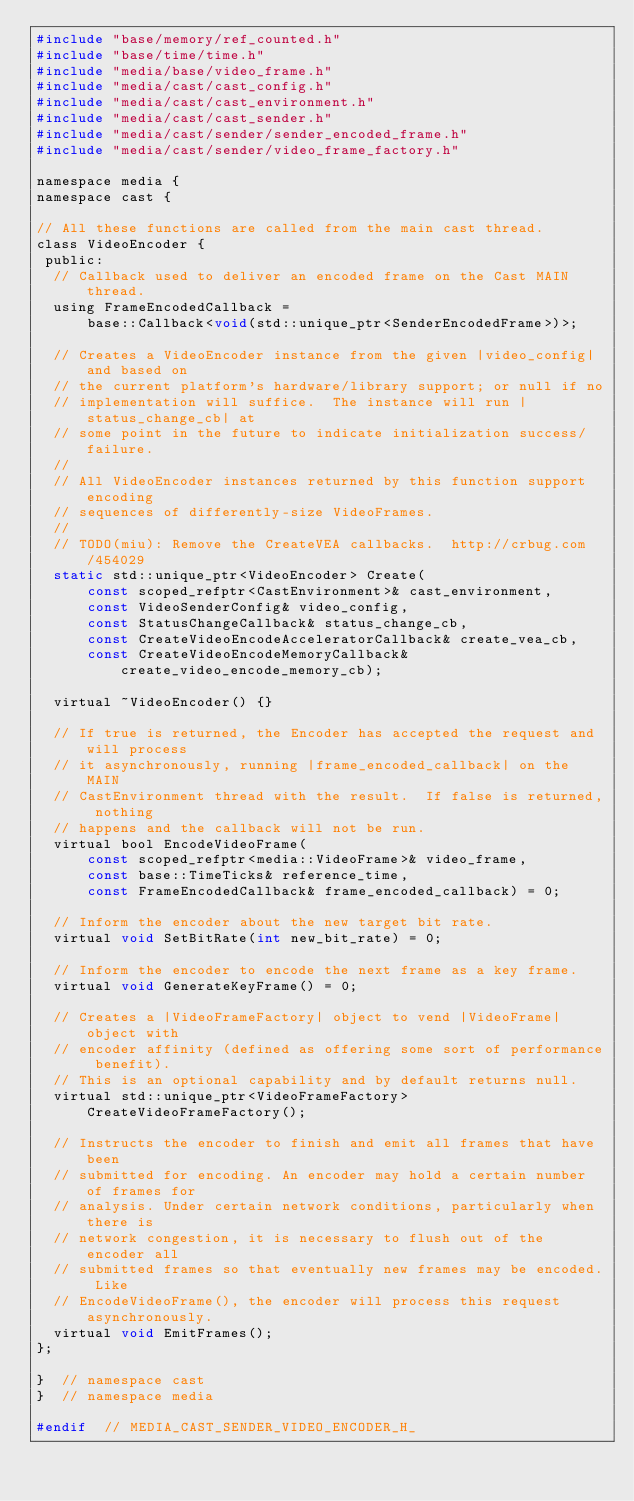Convert code to text. <code><loc_0><loc_0><loc_500><loc_500><_C_>#include "base/memory/ref_counted.h"
#include "base/time/time.h"
#include "media/base/video_frame.h"
#include "media/cast/cast_config.h"
#include "media/cast/cast_environment.h"
#include "media/cast/cast_sender.h"
#include "media/cast/sender/sender_encoded_frame.h"
#include "media/cast/sender/video_frame_factory.h"

namespace media {
namespace cast {

// All these functions are called from the main cast thread.
class VideoEncoder {
 public:
  // Callback used to deliver an encoded frame on the Cast MAIN thread.
  using FrameEncodedCallback =
      base::Callback<void(std::unique_ptr<SenderEncodedFrame>)>;

  // Creates a VideoEncoder instance from the given |video_config| and based on
  // the current platform's hardware/library support; or null if no
  // implementation will suffice.  The instance will run |status_change_cb| at
  // some point in the future to indicate initialization success/failure.
  //
  // All VideoEncoder instances returned by this function support encoding
  // sequences of differently-size VideoFrames.
  //
  // TODO(miu): Remove the CreateVEA callbacks.  http://crbug.com/454029
  static std::unique_ptr<VideoEncoder> Create(
      const scoped_refptr<CastEnvironment>& cast_environment,
      const VideoSenderConfig& video_config,
      const StatusChangeCallback& status_change_cb,
      const CreateVideoEncodeAcceleratorCallback& create_vea_cb,
      const CreateVideoEncodeMemoryCallback& create_video_encode_memory_cb);

  virtual ~VideoEncoder() {}

  // If true is returned, the Encoder has accepted the request and will process
  // it asynchronously, running |frame_encoded_callback| on the MAIN
  // CastEnvironment thread with the result.  If false is returned, nothing
  // happens and the callback will not be run.
  virtual bool EncodeVideoFrame(
      const scoped_refptr<media::VideoFrame>& video_frame,
      const base::TimeTicks& reference_time,
      const FrameEncodedCallback& frame_encoded_callback) = 0;

  // Inform the encoder about the new target bit rate.
  virtual void SetBitRate(int new_bit_rate) = 0;

  // Inform the encoder to encode the next frame as a key frame.
  virtual void GenerateKeyFrame() = 0;

  // Creates a |VideoFrameFactory| object to vend |VideoFrame| object with
  // encoder affinity (defined as offering some sort of performance benefit).
  // This is an optional capability and by default returns null.
  virtual std::unique_ptr<VideoFrameFactory> CreateVideoFrameFactory();

  // Instructs the encoder to finish and emit all frames that have been
  // submitted for encoding. An encoder may hold a certain number of frames for
  // analysis. Under certain network conditions, particularly when there is
  // network congestion, it is necessary to flush out of the encoder all
  // submitted frames so that eventually new frames may be encoded. Like
  // EncodeVideoFrame(), the encoder will process this request asynchronously.
  virtual void EmitFrames();
};

}  // namespace cast
}  // namespace media

#endif  // MEDIA_CAST_SENDER_VIDEO_ENCODER_H_
</code> 